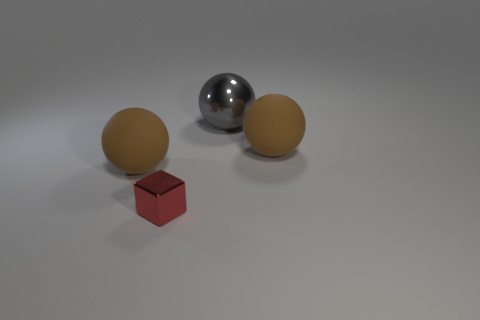There is a tiny red thing that is to the left of the shiny ball that is behind the tiny red thing; is there a rubber ball that is right of it?
Your answer should be very brief. Yes. Is there a sphere that has the same size as the gray metal thing?
Offer a terse response. Yes. There is a thing that is to the right of the gray thing; how big is it?
Offer a terse response. Large. There is a rubber object that is behind the large ball left of the metallic object that is on the right side of the block; what color is it?
Your answer should be very brief. Brown. The matte object behind the big rubber thing left of the cube is what color?
Ensure brevity in your answer.  Brown. Is the number of big metal spheres that are left of the gray thing greater than the number of blocks behind the tiny red block?
Make the answer very short. No. Are the brown sphere that is to the left of the large metal ball and the brown ball right of the gray object made of the same material?
Keep it short and to the point. Yes. There is a tiny shiny block; are there any big brown rubber objects in front of it?
Your response must be concise. No. What number of gray objects are either rubber things or large metal balls?
Keep it short and to the point. 1. Are the gray object and the big brown sphere that is to the left of the big metal sphere made of the same material?
Keep it short and to the point. No. 